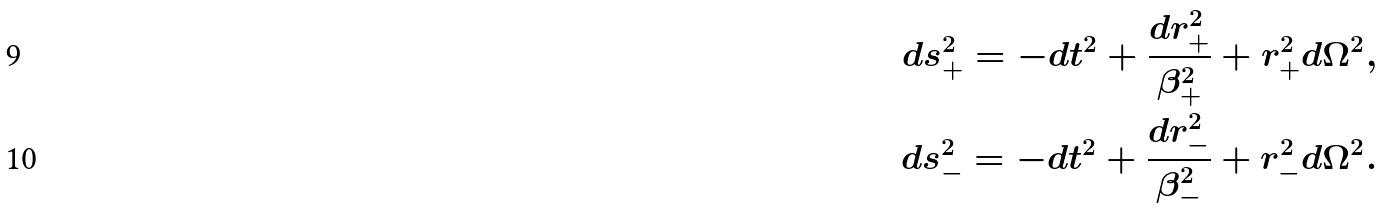<formula> <loc_0><loc_0><loc_500><loc_500>d s ^ { 2 } _ { + } = - d t ^ { 2 } + \frac { d r ^ { 2 } _ { + } } { \beta _ { + } ^ { 2 } } + r _ { + } ^ { 2 } d \Omega ^ { 2 } , \\ d s ^ { 2 } _ { - } = - d t ^ { 2 } + \frac { d r ^ { 2 } _ { - } } { \beta _ { - } ^ { 2 } } + r _ { - } ^ { 2 } d \Omega ^ { 2 } .</formula> 